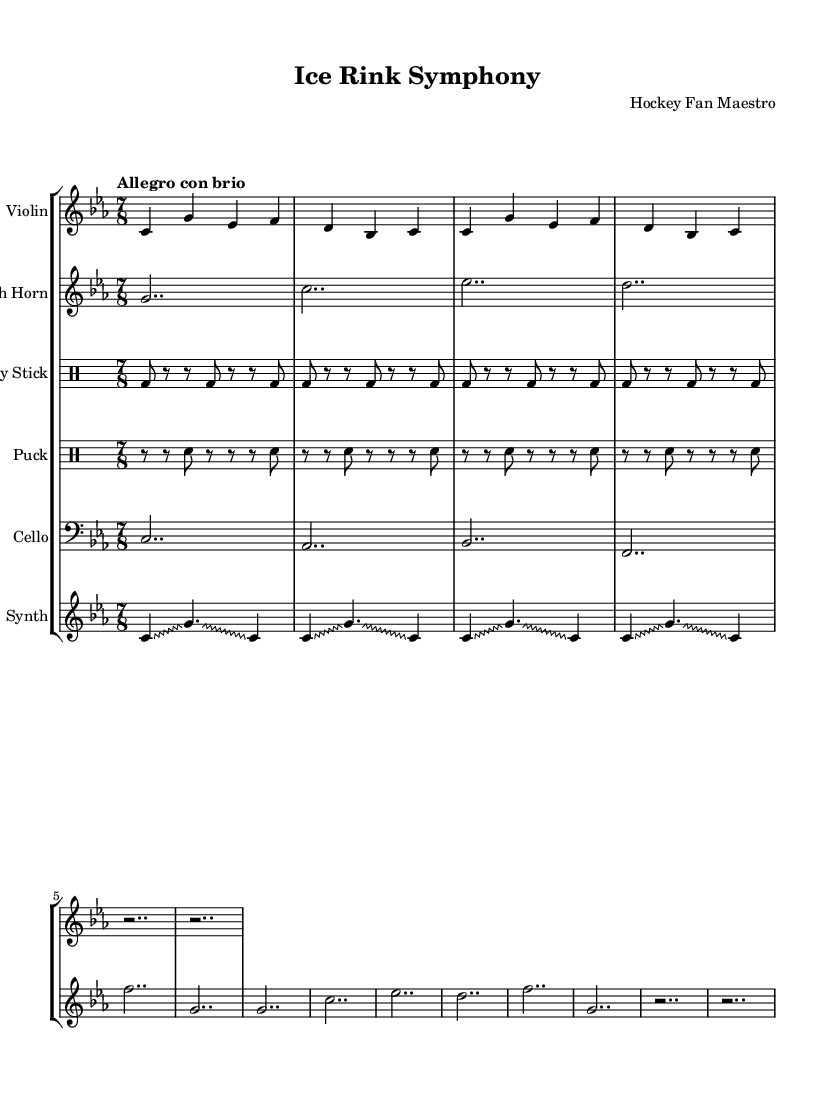What is the key signature of this music? The key signature is C minor, which contains three flats (B♭, E♭, and A♭). This is evident in the global variable section where the key is declared as C minor.
Answer: C minor What is the time signature of this composition? The time signature is 7/8, meaning there are seven beats in each measure, and the eighth note gets one beat. This is stated in the global variable section.
Answer: 7/8 What is the tempo marking of the piece? The tempo marking is "Allegro con brio," which indicates a fast and spirited pace for the composition. This is found in the global section under the tempo declaration.
Answer: Allegro con brio How many parts are there in total? There are six distinct parts in this score: Violin, French Horn, Hockey Stick, Puck, Cello, and Synth. This can be counted in the score section where each staff is introduced.
Answer: Six Which instrument includes hockey stick percussion? The instrument designated as "Hockey Stick" corresponds to the percussion part utilizing hockey sticks for rhythmic elements, specifically found in the drum staff.
Answer: Hockey Stick What technique is used in the synth part? The technique called "Glissando" is employed in the synth part as indicated by the notation and the override for zigzag style. This indicates sliding between notes.
Answer: Glissando What unique elements does this composition incorporate? This composition uniquely incorporates hockey stick percussion and puck sounds as instrumental parts, highlighting the avant-garde experimental style exemplified in this piece.
Answer: Hockey stick percussion and puck sounds 